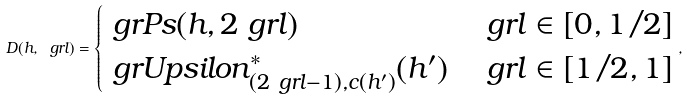<formula> <loc_0><loc_0><loc_500><loc_500>D ( h , \ g r l ) = \begin{cases} \ g r P s ( h , 2 \ g r l ) & \ g r l \in [ 0 , 1 / 2 ] \\ \ g r U p s i l o n _ { ( 2 \ g r l - 1 ) , c ( h ^ { \prime } ) } ^ { * } ( h ^ { \prime } ) & \ g r l \in [ 1 / 2 , 1 ] \end{cases} ,</formula> 